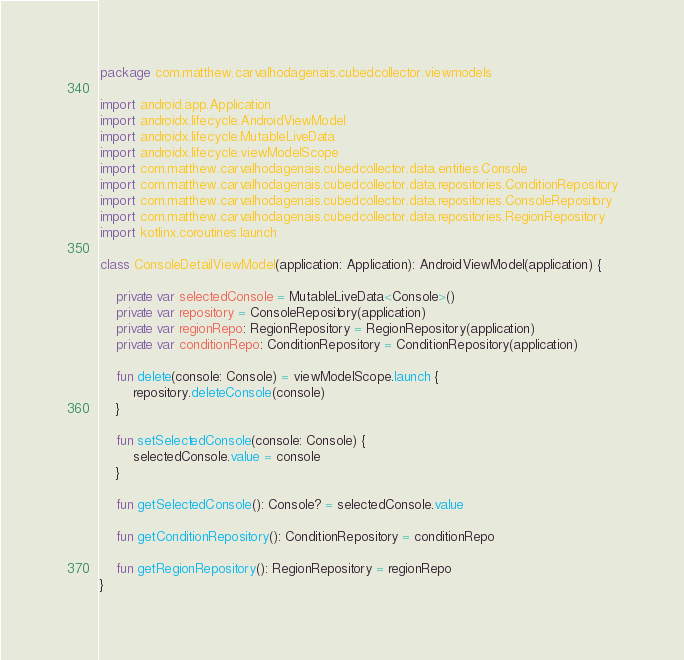Convert code to text. <code><loc_0><loc_0><loc_500><loc_500><_Kotlin_>package com.matthew.carvalhodagenais.cubedcollector.viewmodels

import android.app.Application
import androidx.lifecycle.AndroidViewModel
import androidx.lifecycle.MutableLiveData
import androidx.lifecycle.viewModelScope
import com.matthew.carvalhodagenais.cubedcollector.data.entities.Console
import com.matthew.carvalhodagenais.cubedcollector.data.repositories.ConditionRepository
import com.matthew.carvalhodagenais.cubedcollector.data.repositories.ConsoleRepository
import com.matthew.carvalhodagenais.cubedcollector.data.repositories.RegionRepository
import kotlinx.coroutines.launch

class ConsoleDetailViewModel(application: Application): AndroidViewModel(application) {

    private var selectedConsole = MutableLiveData<Console>()
    private var repository = ConsoleRepository(application)
    private var regionRepo: RegionRepository = RegionRepository(application)
    private var conditionRepo: ConditionRepository = ConditionRepository(application)

    fun delete(console: Console) = viewModelScope.launch {
        repository.deleteConsole(console)
    }

    fun setSelectedConsole(console: Console) {
        selectedConsole.value = console
    }

    fun getSelectedConsole(): Console? = selectedConsole.value

    fun getConditionRepository(): ConditionRepository = conditionRepo

    fun getRegionRepository(): RegionRepository = regionRepo
}</code> 